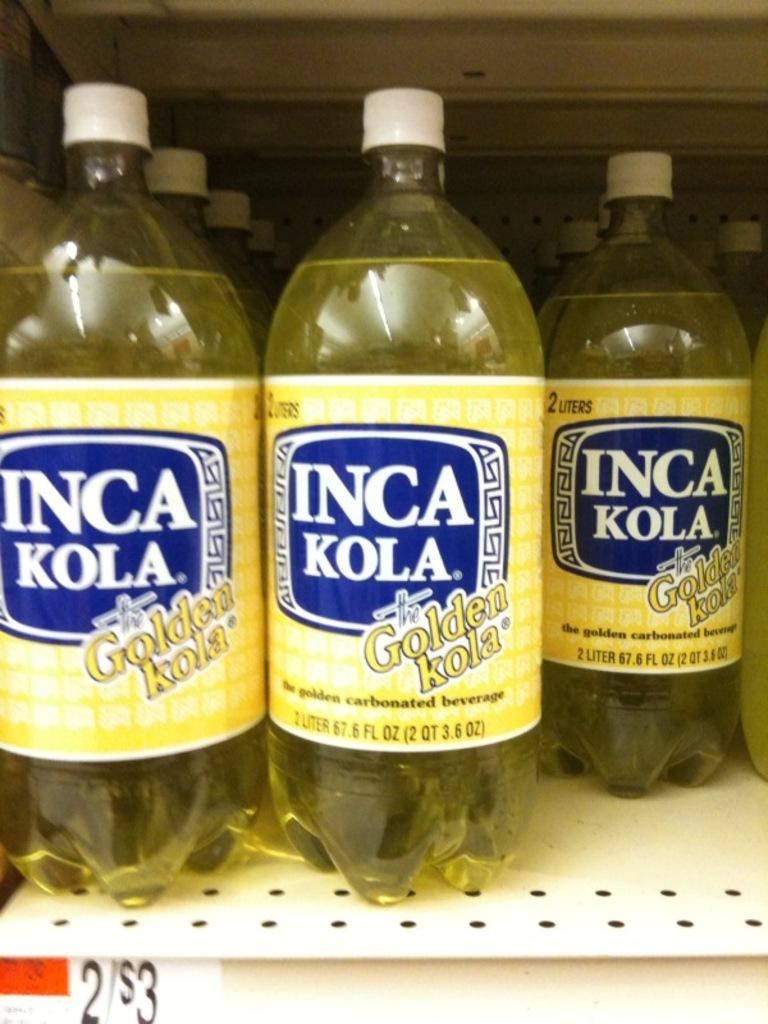What brand is this soda?
Ensure brevity in your answer.  Inca kola. How many quarts are in this bottle?
Provide a succinct answer. 2. 